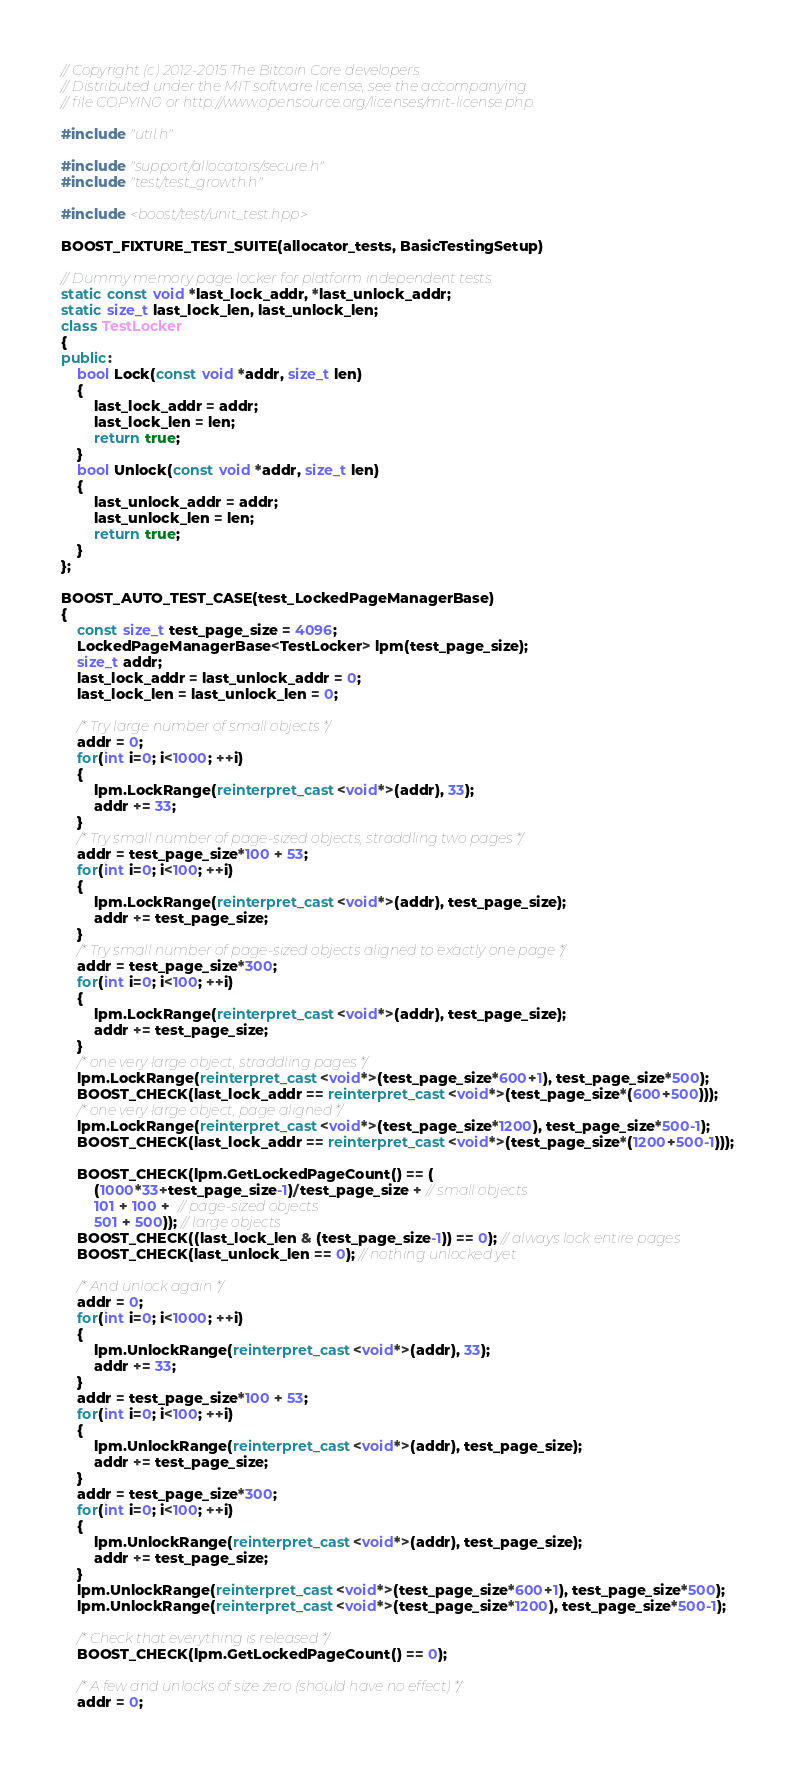Convert code to text. <code><loc_0><loc_0><loc_500><loc_500><_C++_>// Copyright (c) 2012-2015 The Bitcoin Core developers
// Distributed under the MIT software license, see the accompanying
// file COPYING or http://www.opensource.org/licenses/mit-license.php.

#include "util.h"

#include "support/allocators/secure.h"
#include "test/test_growth.h"

#include <boost/test/unit_test.hpp>

BOOST_FIXTURE_TEST_SUITE(allocator_tests, BasicTestingSetup)

// Dummy memory page locker for platform independent tests
static const void *last_lock_addr, *last_unlock_addr;
static size_t last_lock_len, last_unlock_len;
class TestLocker
{
public:
    bool Lock(const void *addr, size_t len)
    {
        last_lock_addr = addr;
        last_lock_len = len;
        return true;
    }
    bool Unlock(const void *addr, size_t len)
    {
        last_unlock_addr = addr;
        last_unlock_len = len;
        return true;
    }
};

BOOST_AUTO_TEST_CASE(test_LockedPageManagerBase)
{
    const size_t test_page_size = 4096;
    LockedPageManagerBase<TestLocker> lpm(test_page_size);
    size_t addr;
    last_lock_addr = last_unlock_addr = 0;
    last_lock_len = last_unlock_len = 0;

    /* Try large number of small objects */
    addr = 0;
    for(int i=0; i<1000; ++i)
    {
        lpm.LockRange(reinterpret_cast<void*>(addr), 33);
        addr += 33;
    }
    /* Try small number of page-sized objects, straddling two pages */
    addr = test_page_size*100 + 53;
    for(int i=0; i<100; ++i)
    {
        lpm.LockRange(reinterpret_cast<void*>(addr), test_page_size);
        addr += test_page_size;
    }
    /* Try small number of page-sized objects aligned to exactly one page */
    addr = test_page_size*300;
    for(int i=0; i<100; ++i)
    {
        lpm.LockRange(reinterpret_cast<void*>(addr), test_page_size);
        addr += test_page_size;
    }
    /* one very large object, straddling pages */
    lpm.LockRange(reinterpret_cast<void*>(test_page_size*600+1), test_page_size*500);
    BOOST_CHECK(last_lock_addr == reinterpret_cast<void*>(test_page_size*(600+500)));
    /* one very large object, page aligned */
    lpm.LockRange(reinterpret_cast<void*>(test_page_size*1200), test_page_size*500-1);
    BOOST_CHECK(last_lock_addr == reinterpret_cast<void*>(test_page_size*(1200+500-1)));

    BOOST_CHECK(lpm.GetLockedPageCount() == (
        (1000*33+test_page_size-1)/test_page_size + // small objects
        101 + 100 +  // page-sized objects
        501 + 500)); // large objects
    BOOST_CHECK((last_lock_len & (test_page_size-1)) == 0); // always lock entire pages
    BOOST_CHECK(last_unlock_len == 0); // nothing unlocked yet

    /* And unlock again */
    addr = 0;
    for(int i=0; i<1000; ++i)
    {
        lpm.UnlockRange(reinterpret_cast<void*>(addr), 33);
        addr += 33;
    }
    addr = test_page_size*100 + 53;
    for(int i=0; i<100; ++i)
    {
        lpm.UnlockRange(reinterpret_cast<void*>(addr), test_page_size);
        addr += test_page_size;
    }
    addr = test_page_size*300;
    for(int i=0; i<100; ++i)
    {
        lpm.UnlockRange(reinterpret_cast<void*>(addr), test_page_size);
        addr += test_page_size;
    }
    lpm.UnlockRange(reinterpret_cast<void*>(test_page_size*600+1), test_page_size*500);
    lpm.UnlockRange(reinterpret_cast<void*>(test_page_size*1200), test_page_size*500-1);

    /* Check that everything is released */
    BOOST_CHECK(lpm.GetLockedPageCount() == 0);

    /* A few and unlocks of size zero (should have no effect) */
    addr = 0;</code> 